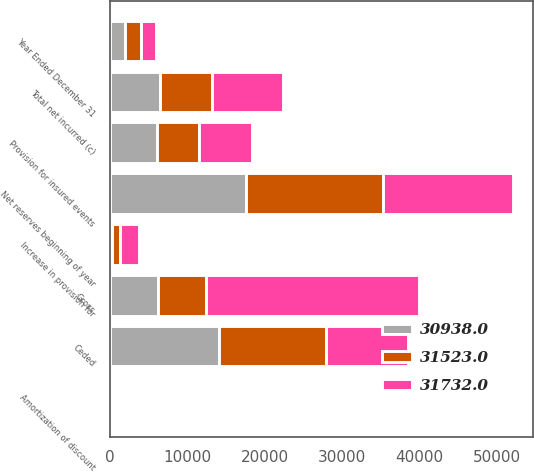Convert chart. <chart><loc_0><loc_0><loc_500><loc_500><stacked_bar_chart><ecel><fcel>Year Ended December 31<fcel>Gross<fcel>Ceded<fcel>Net reserves beginning of year<fcel>Provision for insured events<fcel>Increase in provision for<fcel>Amortization of discount<fcel>Total net incurred (c)<nl><fcel>31523<fcel>2005<fcel>6249.5<fcel>13879<fcel>17644<fcel>5516<fcel>1100<fcel>115<fcel>6731<nl><fcel>30938<fcel>2004<fcel>6249.5<fcel>14066<fcel>17666<fcel>6062<fcel>240<fcel>135<fcel>6437<nl><fcel>31732<fcel>2003<fcel>27441<fcel>10634<fcel>16807<fcel>6745<fcel>2398<fcel>115<fcel>9258<nl></chart> 